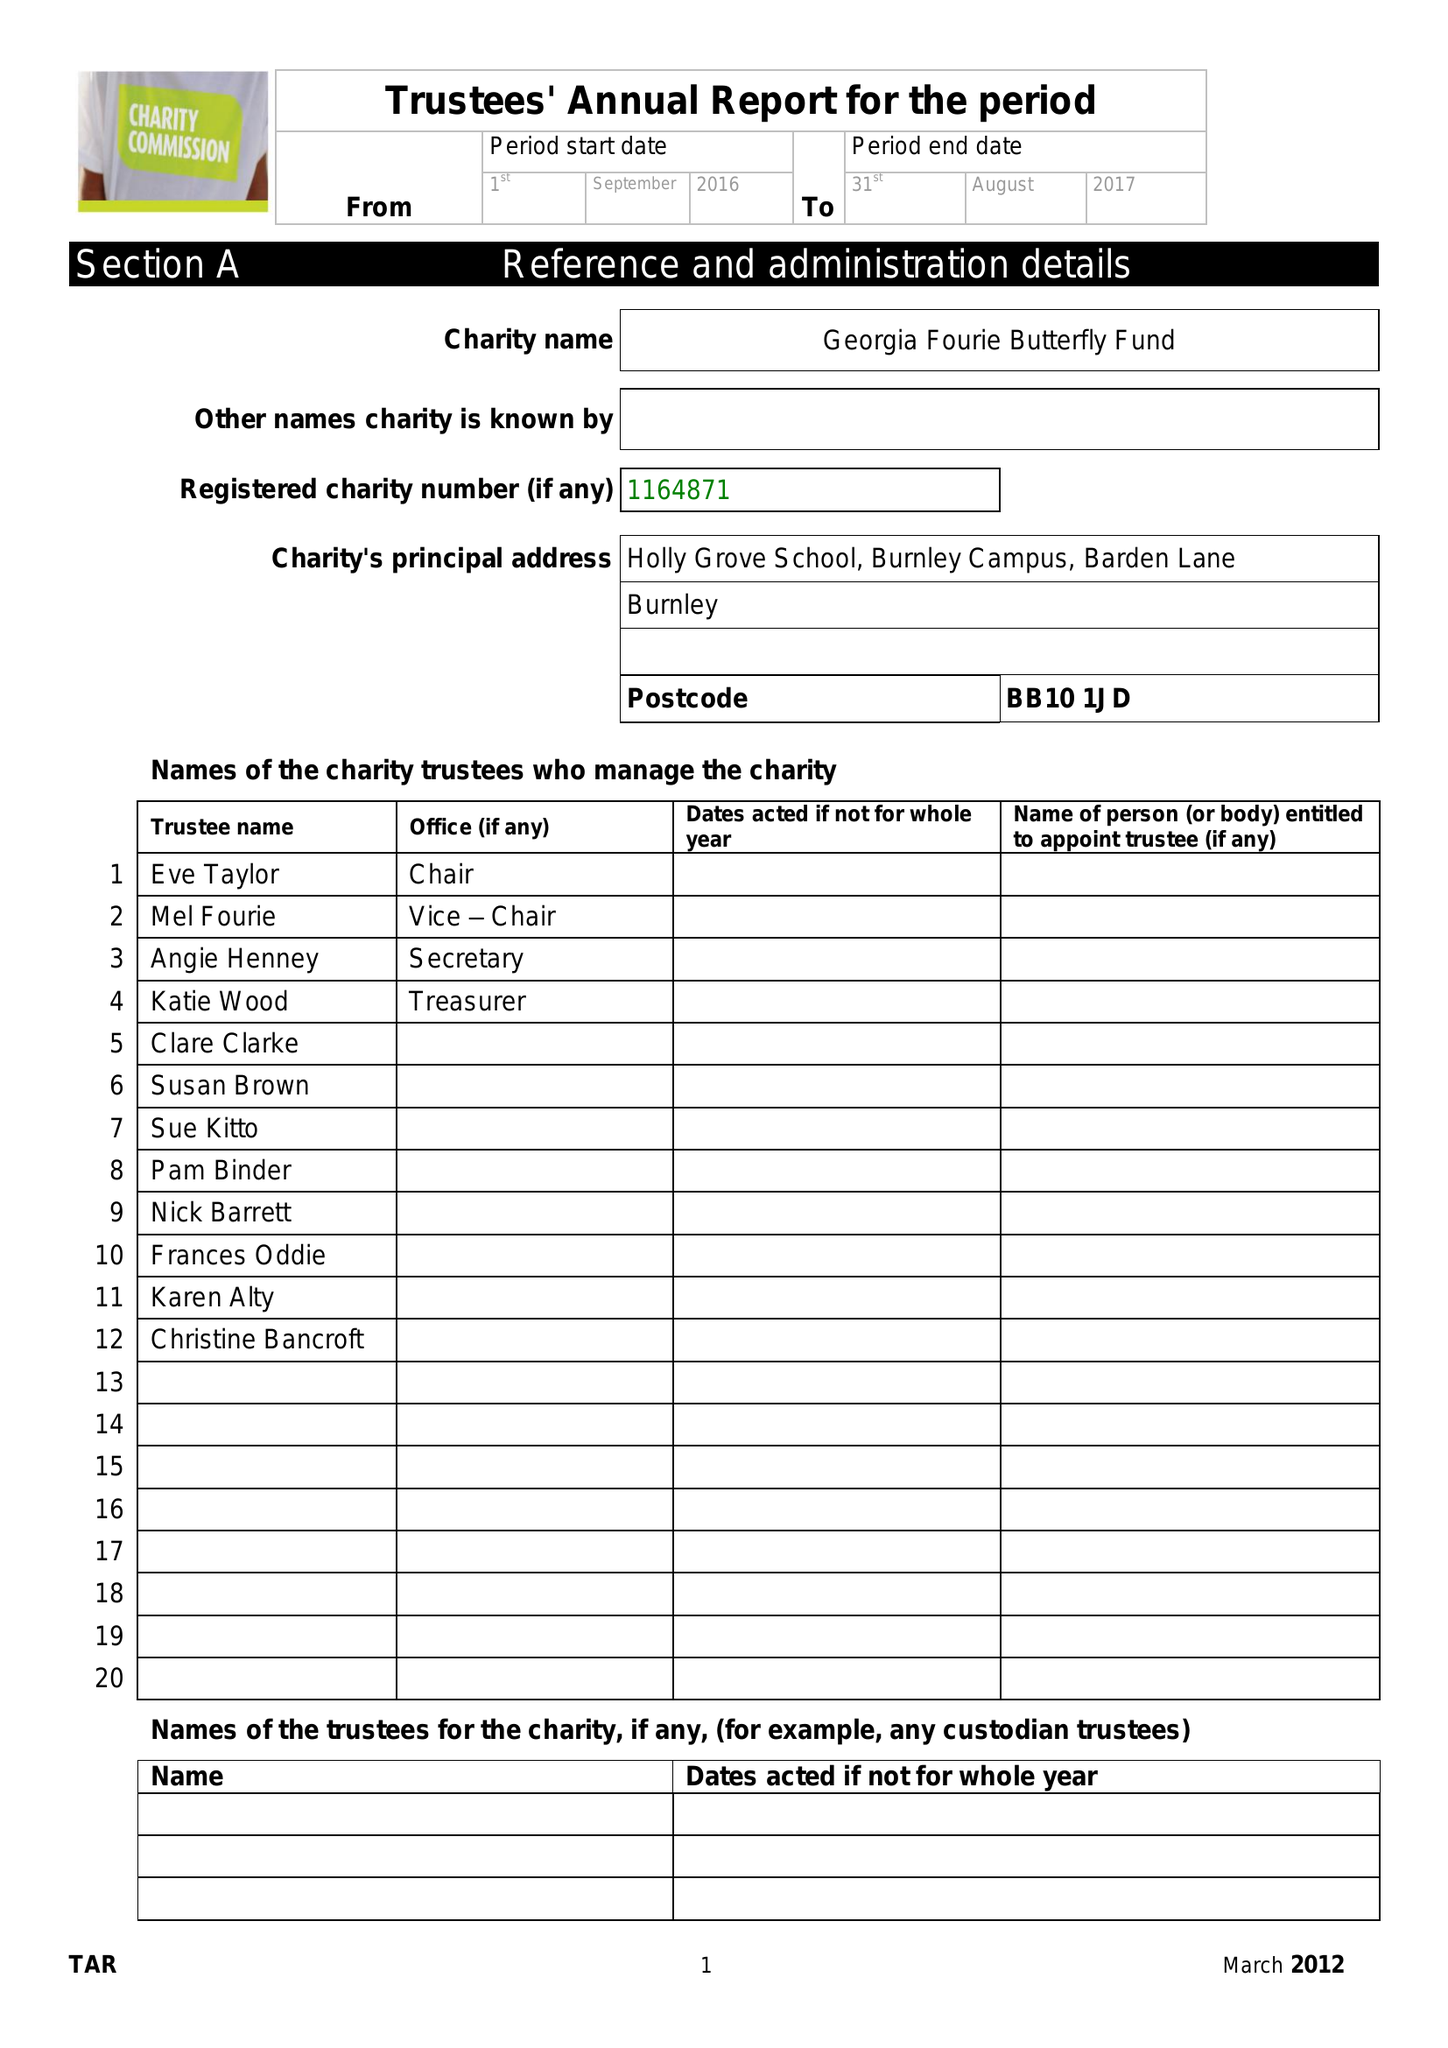What is the value for the charity_number?
Answer the question using a single word or phrase. 1164871 